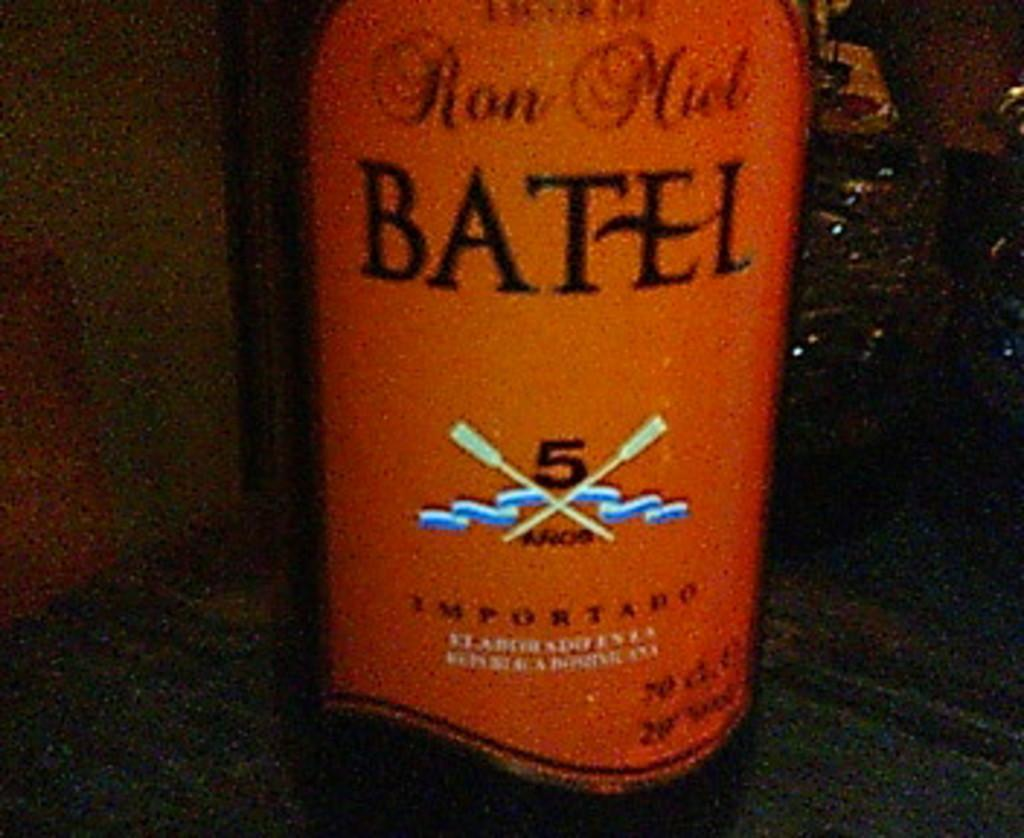<image>
Provide a brief description of the given image. A bottle of imported Ron Miel Batel sits on a table. 